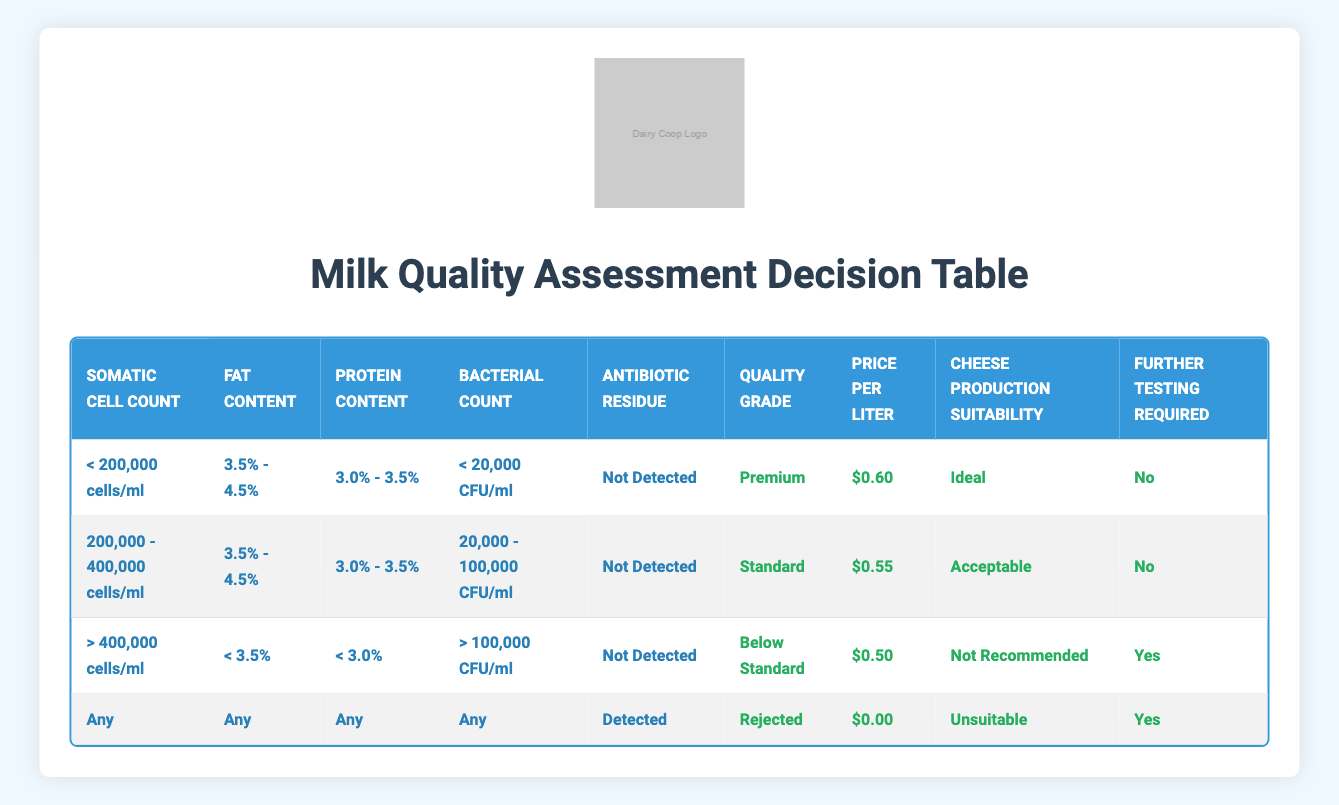What is the quality grade for milk with a somatic cell count of less than 200,000 cells/ml, a fat content of 3.5% to 4.5%, protein content of 3.0% to 3.5%, a bacterial count less than 20,000 CFU/ml, and no antibiotic residue? According to the first row of the table, all the specified conditions (somatic cell count, fat content, protein content, bacterial count, and antibiotic residue) match the conditions leading to a quality grade of "Premium."
Answer: Premium What is the price per liter of milk with a bacterial count between 20,000 and 100,000 CFU/ml and a somatic cell count of 200,000 to 400,000 cells/ml, assuming there is no antibiotic residue? The second row of the table specifies that with those conditions, the price per liter is listed as "$0.55."
Answer: $0.55 Is milk with antibiotic residue detected graded below standard? The table indicates that any milk with detected antibiotic residue is classified as "Rejected," which does not fall under "Below Standard." Hence, the answer is no.
Answer: No What are the conditions that yield a "Rejected" quality grade? The last rule in the table states that any conditions where antibiotic residue is detected lead to the "Rejected" grade, regardless of other factors.
Answer: Any conditions with detected antibiotic residue If the fat content is above 4.5% and the somatic cell count is greater than 400,000 cells/ml, what is the cheese production suitability? According to the third row, although the specific fat content is not listed, it reports a bacterial count of greater than 100,000 CFU/ml and does not explicitly mention cheese production suitability. This suggests it may be "Not Recommended."
Answer: Not Recommended How many price per liter options are there for milk graded as "Standard"? The table shows only one price per liter for milk graded as "Standard," which is "$0.55." Thus, there is only one option available.
Answer: 1 What is the average fat content range for the "Premium" quality grade milk? The only fat content range under the "Premium" quality grade established in the table is between 3.5% and 4.5%. Since there is just this single range, the average is also the same.
Answer: 3.5% - 4.5% What indicates the need for further testing for milk graded as "Below Standard"? According to the third row of the table, it specifies that further testing is needed if the conditions include a somatic cell count greater than 400,000 cells/ml, fat content under 3.5%, protein content under 3.0%, and a bacterial count over 100,000 CFU/ml.
Answer: Yes 